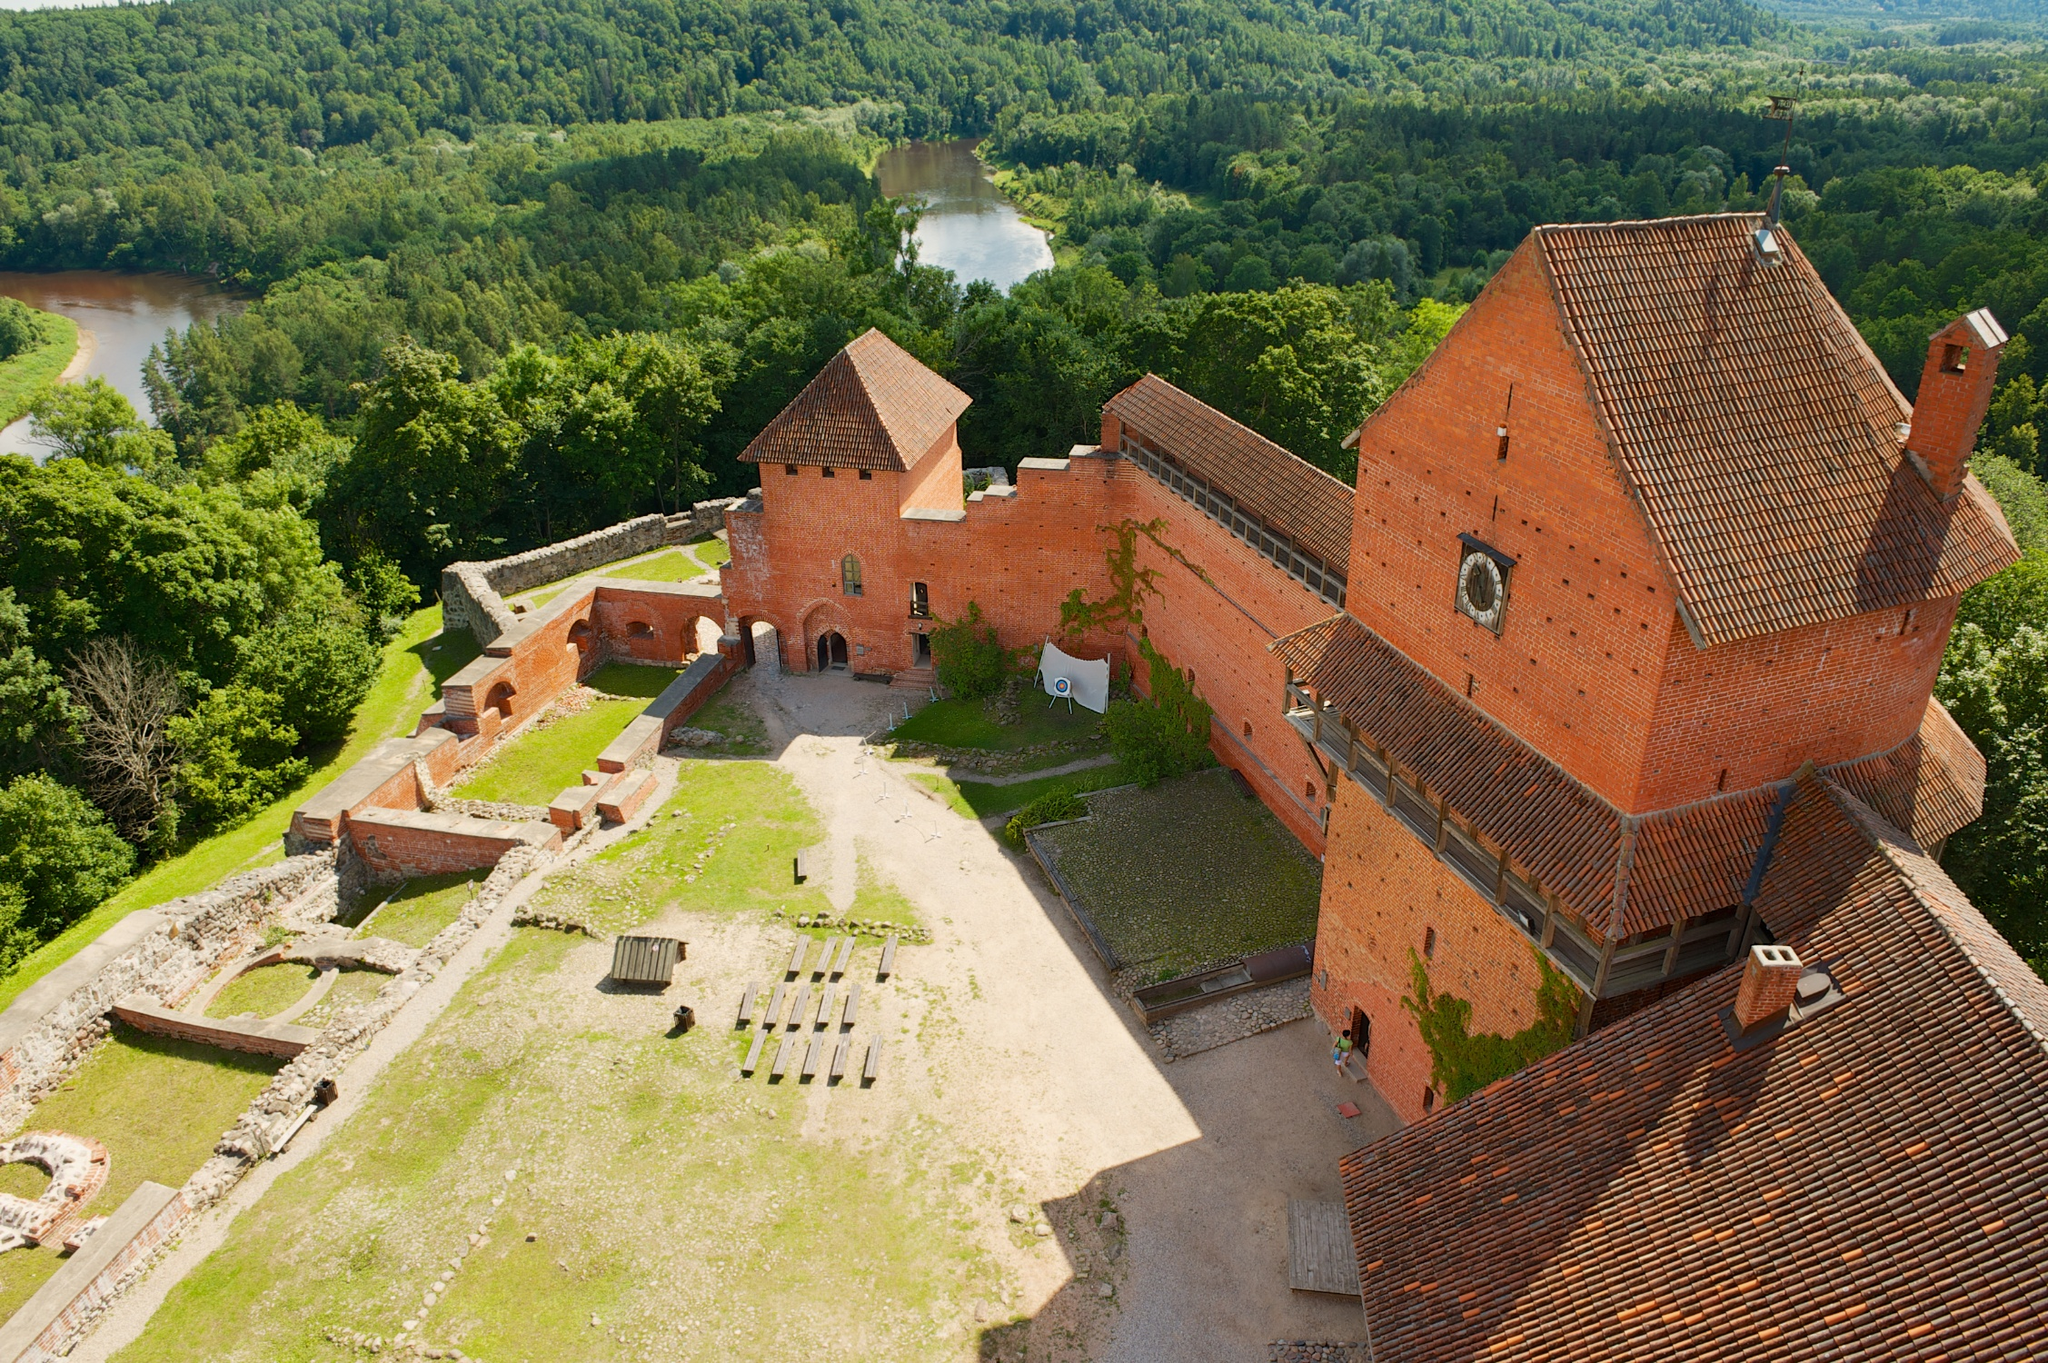Can you tell me more about the history of this castle? This castle, constructed primarily from red brick, dates back to the medieval era, serving as a fortification and a residence for nobility. The architecture reflects a blend of defensive design and residential comfort. Over the centuries, it has witnessed numerous historic events, including battles, sieges, and political intrigues. The castle's strategic location on a hill provided a vantage point for monitoring and defense, contributing to its historical significance. Today, it stands as a testament to medieval engineering and a symbol of regional heritage. 